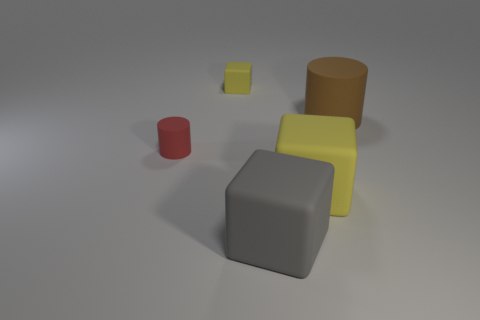There is a tiny object that is to the left of the small rubber thing behind the small red matte object; what shape is it? The tiny object to the left of the small rubber item, which is behind the small red matte object, is a cylinder. It appears to have circular ends and a long straight body, typical characteristics of a cylindrical shape. 